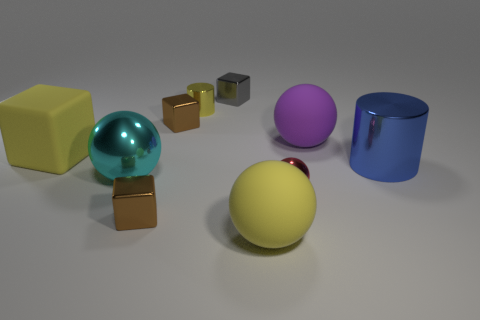Is the color of the large matte object in front of the red metallic object the same as the small cylinder?
Ensure brevity in your answer.  Yes. There is a metal object that is the same color as the big block; what is its shape?
Offer a terse response. Cylinder. How many gray shiny objects have the same shape as the large purple matte object?
Make the answer very short. 0. What color is the metal cylinder that is the same size as the rubber block?
Offer a very short reply. Blue. Is there a large metal thing?
Your answer should be compact. Yes. There is a small object on the right side of the gray block; what is its shape?
Make the answer very short. Sphere. How many things are both in front of the big cylinder and on the right side of the small cylinder?
Offer a terse response. 2. Is there a blue cylinder that has the same material as the cyan sphere?
Your answer should be very brief. Yes. The metallic cylinder that is the same color as the matte block is what size?
Offer a terse response. Small. How many cylinders are tiny metal things or metal objects?
Give a very brief answer. 2. 